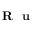Convert formula to latex. <formula><loc_0><loc_0><loc_500><loc_500>R u</formula> 